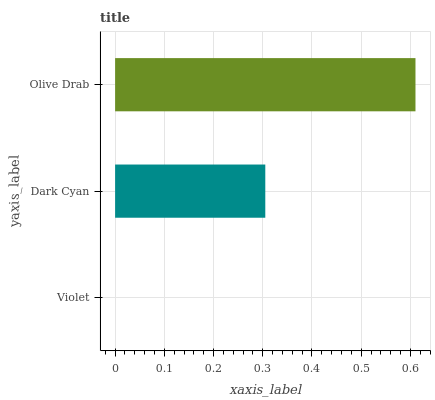Is Violet the minimum?
Answer yes or no. Yes. Is Olive Drab the maximum?
Answer yes or no. Yes. Is Dark Cyan the minimum?
Answer yes or no. No. Is Dark Cyan the maximum?
Answer yes or no. No. Is Dark Cyan greater than Violet?
Answer yes or no. Yes. Is Violet less than Dark Cyan?
Answer yes or no. Yes. Is Violet greater than Dark Cyan?
Answer yes or no. No. Is Dark Cyan less than Violet?
Answer yes or no. No. Is Dark Cyan the high median?
Answer yes or no. Yes. Is Dark Cyan the low median?
Answer yes or no. Yes. Is Violet the high median?
Answer yes or no. No. Is Olive Drab the low median?
Answer yes or no. No. 